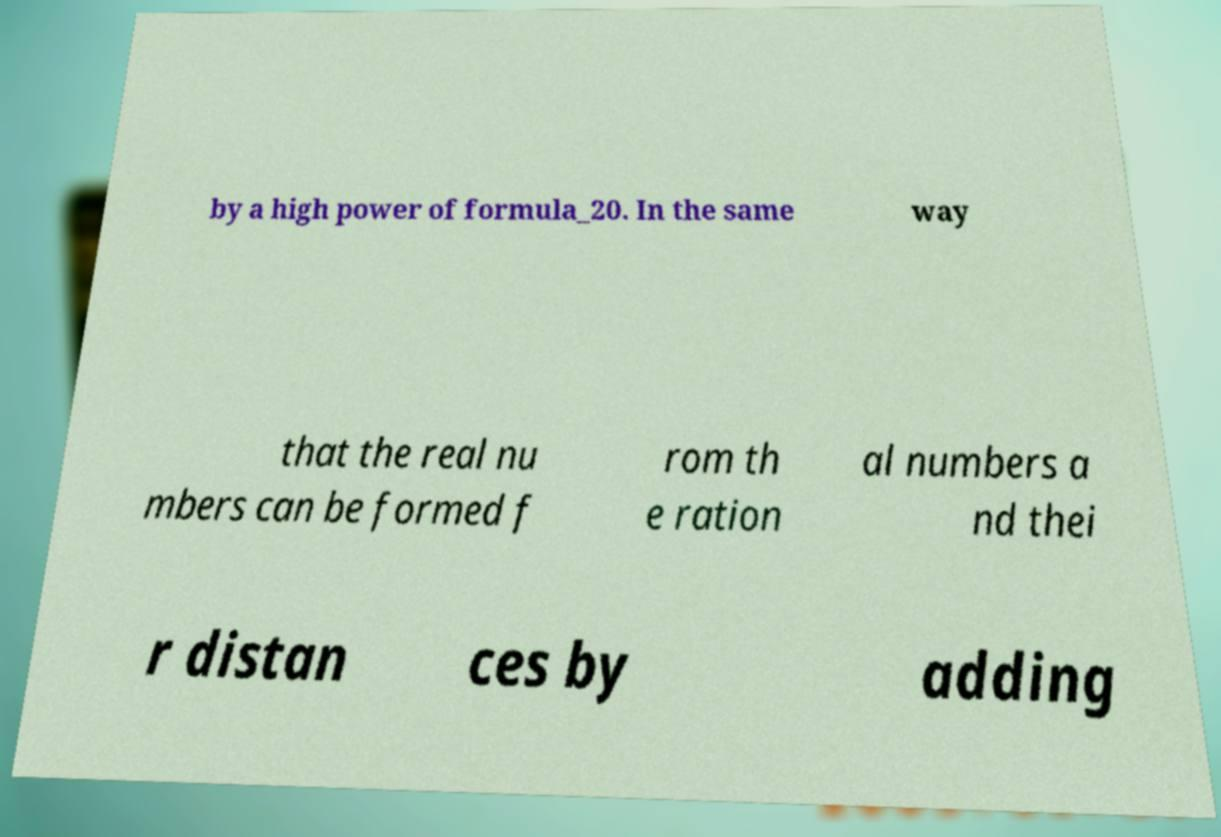Can you read and provide the text displayed in the image?This photo seems to have some interesting text. Can you extract and type it out for me? by a high power of formula_20. In the same way that the real nu mbers can be formed f rom th e ration al numbers a nd thei r distan ces by adding 